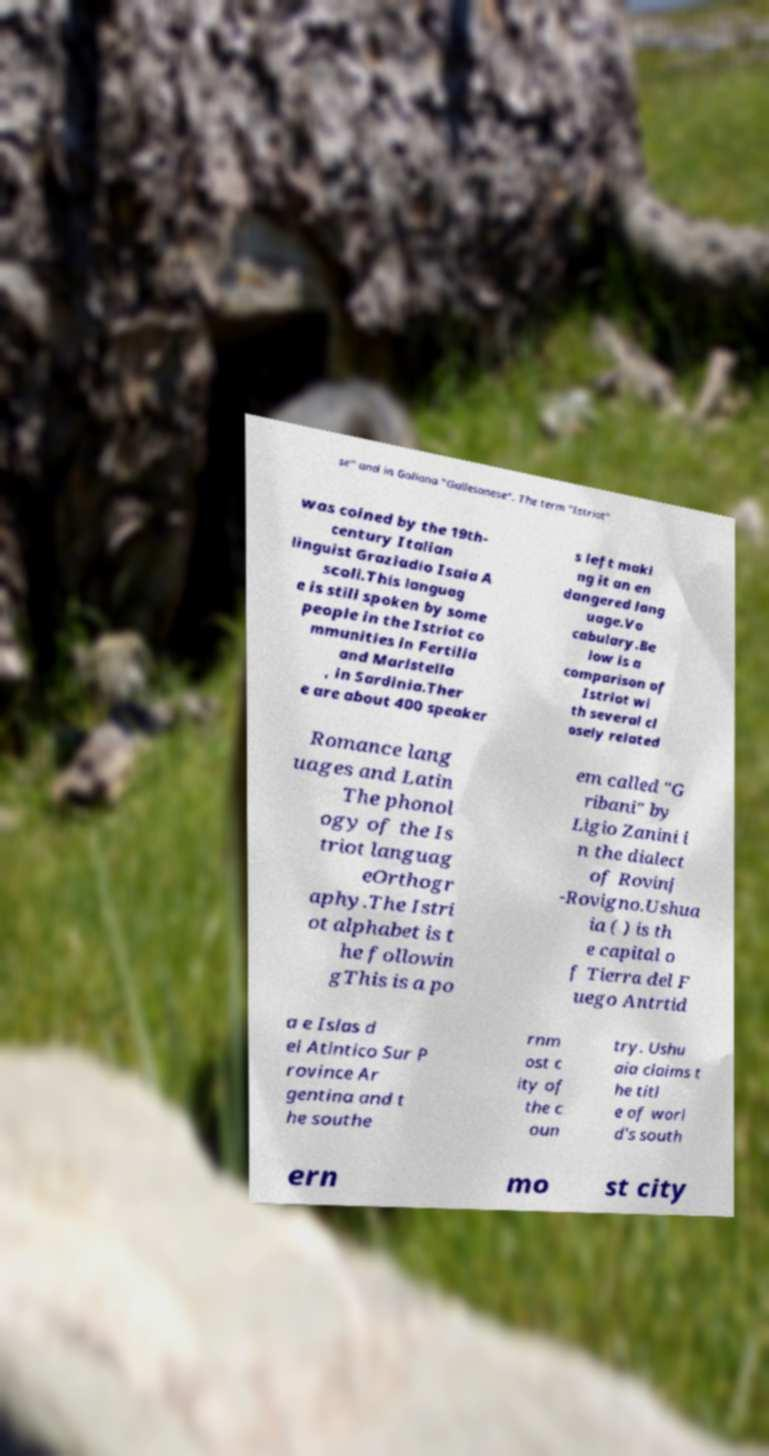Can you read and provide the text displayed in the image?This photo seems to have some interesting text. Can you extract and type it out for me? se" and in Galiana "Gallesanese". The term "Istriot" was coined by the 19th- century Italian linguist Graziadio Isaia A scoli.This languag e is still spoken by some people in the Istriot co mmunities in Fertilia and Maristella , in Sardinia.Ther e are about 400 speaker s left maki ng it an en dangered lang uage.Vo cabulary.Be low is a comparison of Istriot wi th several cl osely related Romance lang uages and Latin The phonol ogy of the Is triot languag eOrthogr aphy.The Istri ot alphabet is t he followin gThis is a po em called "G ribani" by Ligio Zanini i n the dialect of Rovinj -Rovigno.Ushua ia ( ) is th e capital o f Tierra del F uego Antrtid a e Islas d el Atlntico Sur P rovince Ar gentina and t he southe rnm ost c ity of the c oun try. Ushu aia claims t he titl e of worl d's south ern mo st city 